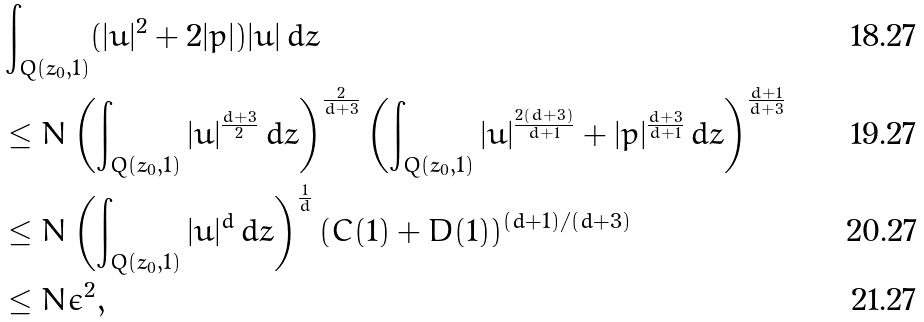<formula> <loc_0><loc_0><loc_500><loc_500>& \int _ { Q ( z _ { 0 } , 1 ) } ( | u | ^ { 2 } + 2 | p | ) | u | \, d z \\ & \leq N \left ( \int _ { Q ( z _ { 0 } , 1 ) } | u | ^ { \frac { d + 3 } { 2 } } \, d z \right ) ^ { \frac { 2 } { d + 3 } } \left ( \int _ { Q ( z _ { 0 } , 1 ) } | u | ^ { \frac { 2 ( d + 3 ) } { d + 1 } } + | p | ^ { \frac { d + 3 } { d + 1 } } \, d z \right ) ^ { \frac { d + 1 } { d + 3 } } \\ & \leq N \left ( \int _ { Q ( z _ { 0 } , 1 ) } | u | ^ { d } \, d z \right ) ^ { \frac { 1 } { d } } ( C ( 1 ) + D ( 1 ) ) ^ { ( d + 1 ) / ( d + 3 ) } \\ & \leq N \epsilon ^ { 2 } ,</formula> 